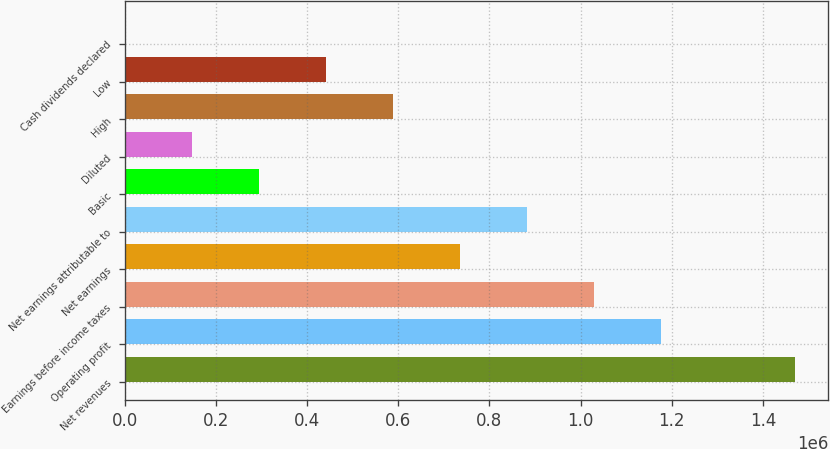Convert chart to OTSL. <chart><loc_0><loc_0><loc_500><loc_500><bar_chart><fcel>Net revenues<fcel>Operating profit<fcel>Earnings before income taxes<fcel>Net earnings<fcel>Net earnings attributable to<fcel>Basic<fcel>Diluted<fcel>High<fcel>Low<fcel>Cash dividends declared<nl><fcel>1.4699e+06<fcel>1.17592e+06<fcel>1.02893e+06<fcel>734950<fcel>881940<fcel>293980<fcel>146990<fcel>587960<fcel>440970<fcel>0.43<nl></chart> 